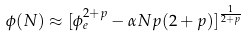<formula> <loc_0><loc_0><loc_500><loc_500>\phi ( N ) \approx [ \phi _ { e } ^ { 2 + p } - \alpha N p ( 2 + p ) ] ^ { \frac { 1 } { 2 + p } }</formula> 